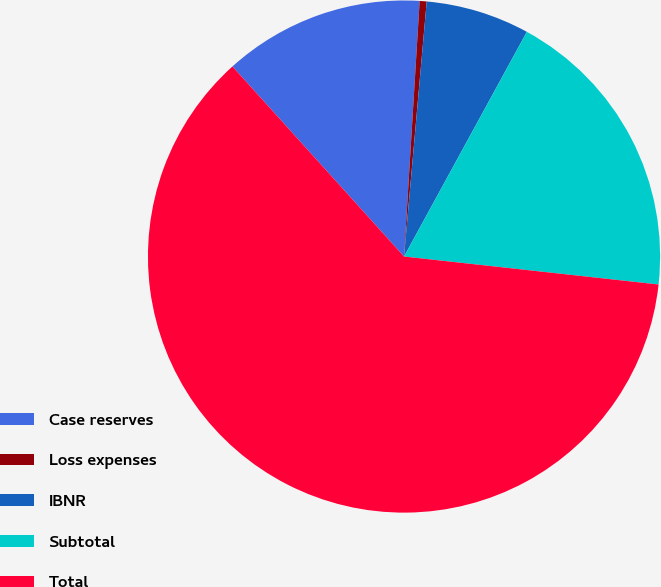Convert chart to OTSL. <chart><loc_0><loc_0><loc_500><loc_500><pie_chart><fcel>Case reserves<fcel>Loss expenses<fcel>IBNR<fcel>Subtotal<fcel>Total<nl><fcel>12.66%<fcel>0.44%<fcel>6.55%<fcel>18.78%<fcel>61.57%<nl></chart> 